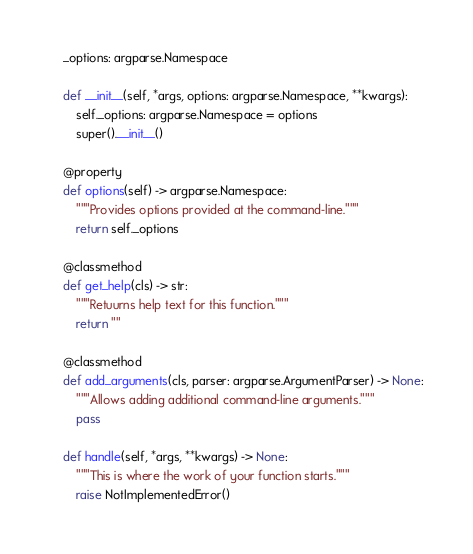<code> <loc_0><loc_0><loc_500><loc_500><_Python_>    _options: argparse.Namespace

    def __init__(self, *args, options: argparse.Namespace, **kwargs):
        self._options: argparse.Namespace = options
        super().__init__()

    @property
    def options(self) -> argparse.Namespace:
        """Provides options provided at the command-line."""
        return self._options

    @classmethod
    def get_help(cls) -> str:
        """Retuurns help text for this function."""
        return ""

    @classmethod
    def add_arguments(cls, parser: argparse.ArgumentParser) -> None:
        """Allows adding additional command-line arguments."""
        pass

    def handle(self, *args, **kwargs) -> None:
        """This is where the work of your function starts."""
        raise NotImplementedError()
</code> 